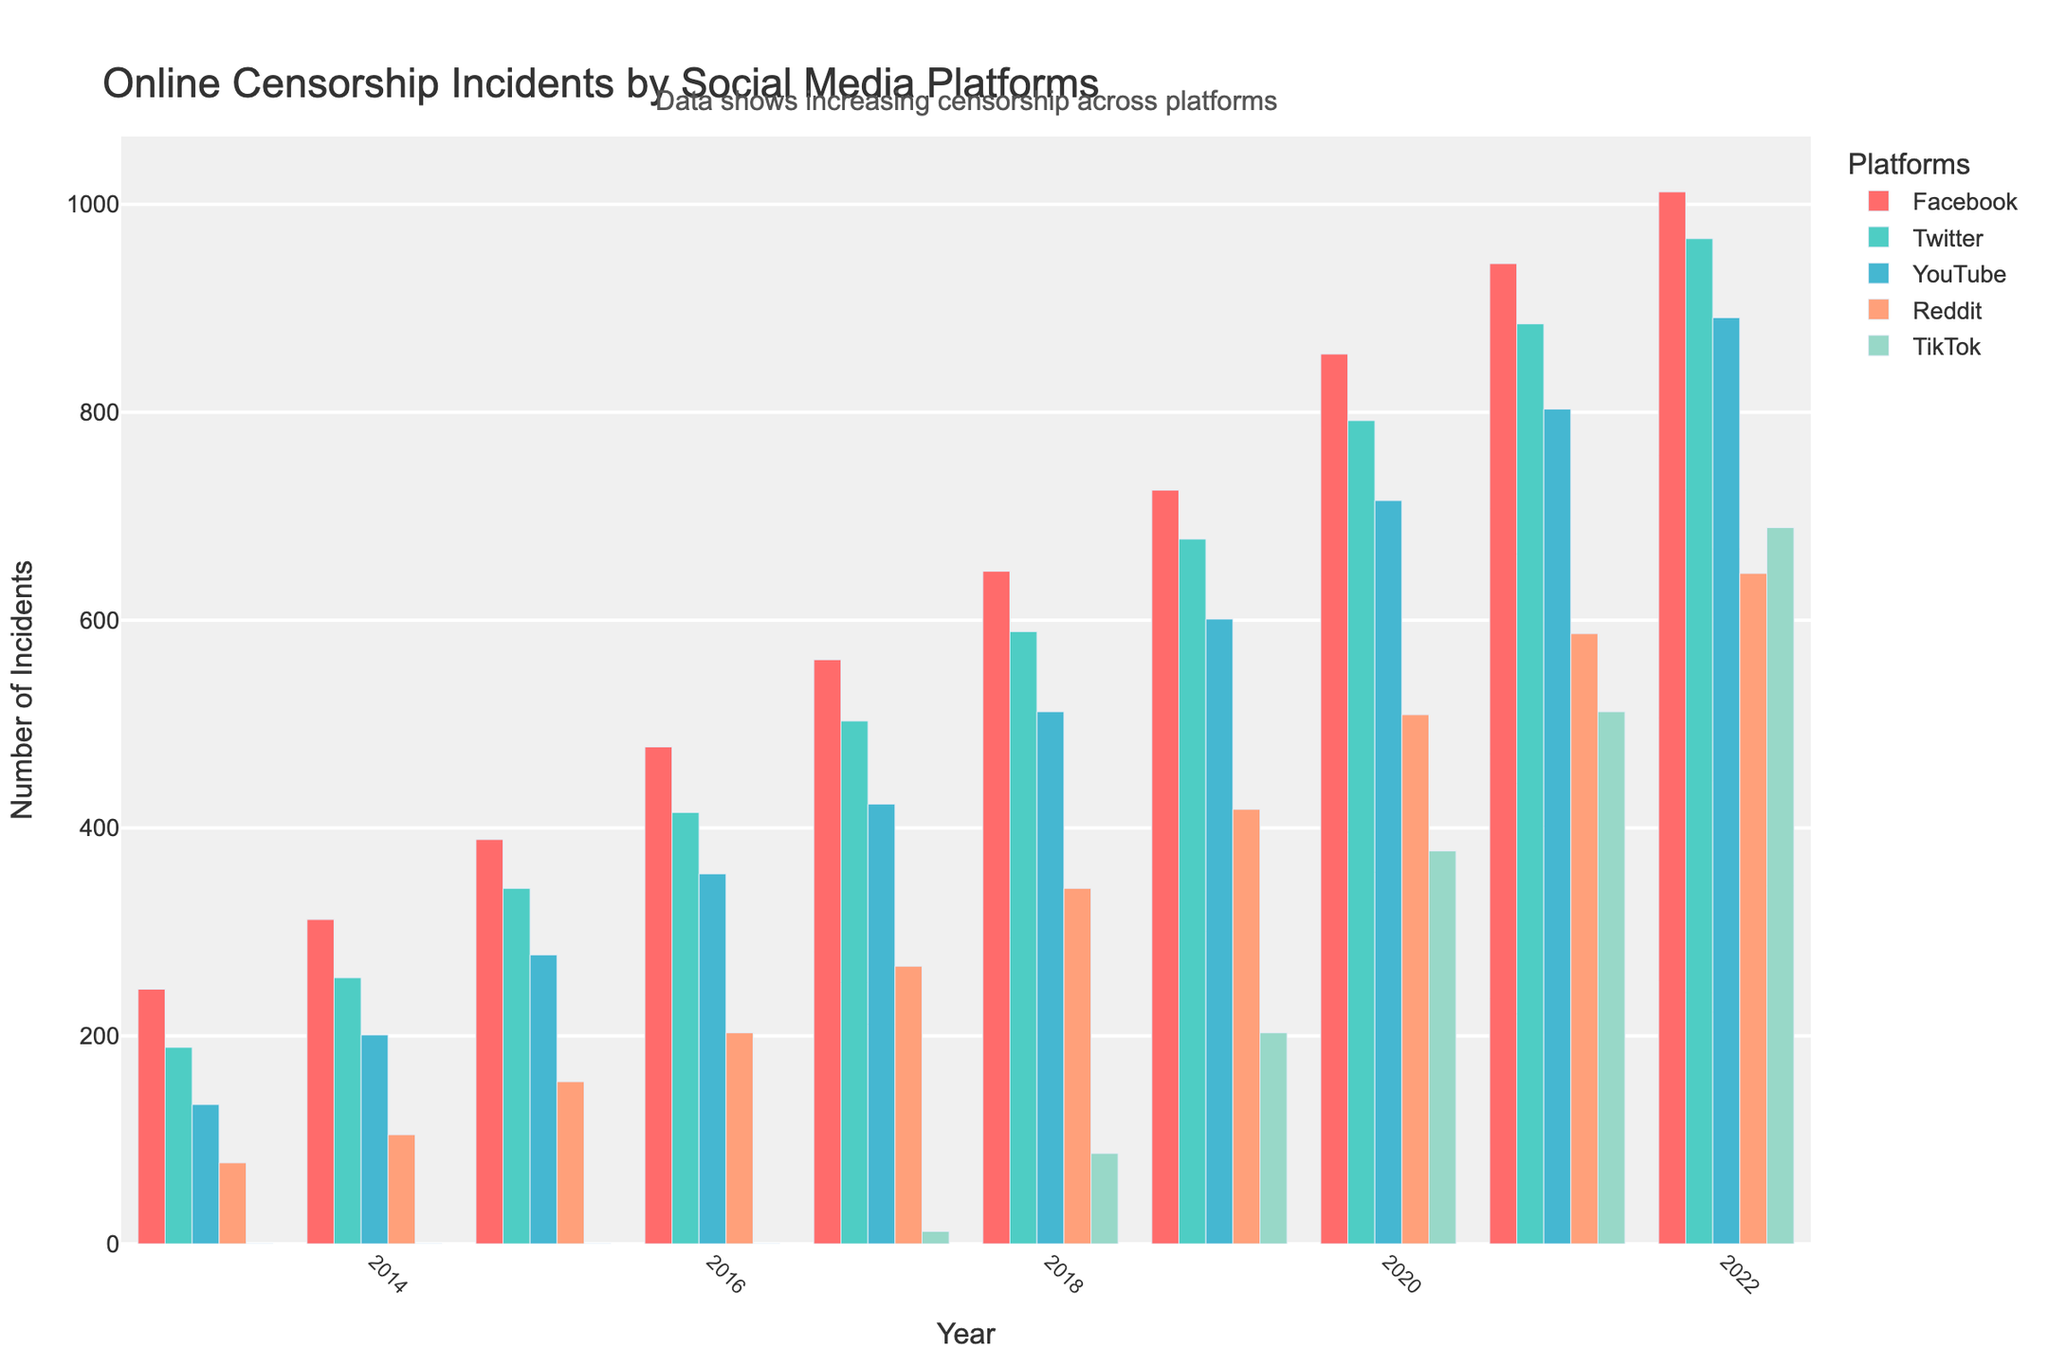What is the trend in online censorship incidents on Facebook from 2013 to 2022? The bars representing Facebook show a consistent increase in the number of incidents each year from 2013 to 2022.
Answer: Increasing trend Which platform had the most significant jump in censorship incidents from 2019 to 2020? By comparing the height of the bars from 2019 to 2020, TikTok had the most notable jump, showing a significant increase from 203 to 378 incidents.
Answer: TikTok In what year did YouTube surpass 500 censorship incidents? The bars for YouTube cross the 500 mark in 2018 where the number of incidents is 512.
Answer: 2018 Compare the number of censorship incidents on Twitter and Reddit in 2020. Which one had more incidents and by how much? Twitter had 792 incidents, and Reddit had 509. Subtracting Reddit's incidents from Twitter's, 792 - 509 = 283 more incidents on Twitter.
Answer: Twitter had 283 more incidents Which social media platform had zero censorship incidents in 2013, and how many did it have in 2022? The bars for TikTok start at zero incidents in 2013 and increase to 689 incidents by 2022.
Answer: TikTok; 689 incidents How many total censorship incidents were recorded across all platforms in 2015? Summing up the number of incidents for all platforms in 2015: 389 (Facebook) + 342 (Twitter) + 278 (YouTube) + 156 (Reddit) + 0 (TikTok) = 1165 incidents.
Answer: 1165 incidents In which year did Facebook have the smallest increase in censorship incidents compared to the previous year? Observing the differences between consecutive years: 
2014-2013: 312-245 = 67
2015-2014: 389-312 = 77
2016-2015: 478-389 = 89
2017-2016: 562-478 = 84
2018-2017: 647-562 = 85
2019-2018: 725-647 = 78
2020-2019: 856-725 = 131
2021-2020: 943-856 = 87
2022-2021: 1012-943 = 69
The smallest increase is from 2013 to 2014.
Answer: 2014 Which two platforms showed the highest and lowest total number of incidents over the past decade? Summing incidents from 2013 to 2022 for each platform:
Facebook: 245+312+389+478+562+647+725+856+943+1012 = 6169
Twitter: 189+256+342+415+503+589+678+792+885+967 = 5616
YouTube: 134+201+278+356+423+512+601+715+803+891 = 4914
Reddit: 78+105+156+203+267+342+418+509+587+645 = 3310
TikTok: 0+0+0+0+12+87+203+378+512+689 = 1881
Facebook had the highest with 6169 incidents, TikTok had the lowest with 1881 incidents.
Answer: Highest: Facebook; Lowest: TikTok When did TikTok record its first online censorship incident, and how many years after the first recorded incidents on other platforms did it occur? TikTok first recorded incidents in 2017 with 12 incidents. Other platforms recorded incidents from 2013. The difference is 2017 - 2013 = 4 years.
Answer: 2017; 4 years after 